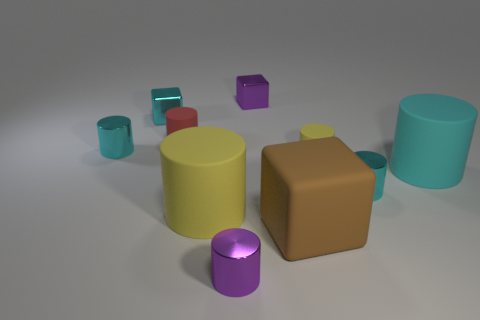Subtract all gray balls. How many cyan cylinders are left? 3 Subtract all cyan cylinders. How many cylinders are left? 4 Subtract all tiny cyan metal cylinders. How many cylinders are left? 5 Subtract all purple cylinders. Subtract all green blocks. How many cylinders are left? 6 Subtract all blocks. How many objects are left? 7 Subtract all yellow things. Subtract all yellow cylinders. How many objects are left? 6 Add 2 red cylinders. How many red cylinders are left? 3 Add 6 small rubber things. How many small rubber things exist? 8 Subtract 0 cyan balls. How many objects are left? 10 